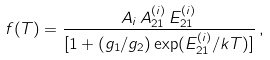<formula> <loc_0><loc_0><loc_500><loc_500>f ( T ) = \frac { A _ { i } \, A ^ { ( i ) } _ { 2 1 } \, E ^ { ( i ) } _ { 2 1 } } { [ 1 + ( g _ { 1 } / g _ { 2 } ) \exp ( E ^ { ( i ) } _ { 2 1 } / k T ) ] } \, ,</formula> 